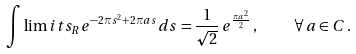Convert formula to latex. <formula><loc_0><loc_0><loc_500><loc_500>\int \lim i t s _ { R } e ^ { - 2 \pi s ^ { 2 } + 2 \pi a s } d s = \frac { 1 } { \sqrt { 2 } } \, e ^ { \frac { \pi a ^ { 2 } } { 2 } } \, , \quad \forall \, a \in C \, .</formula> 